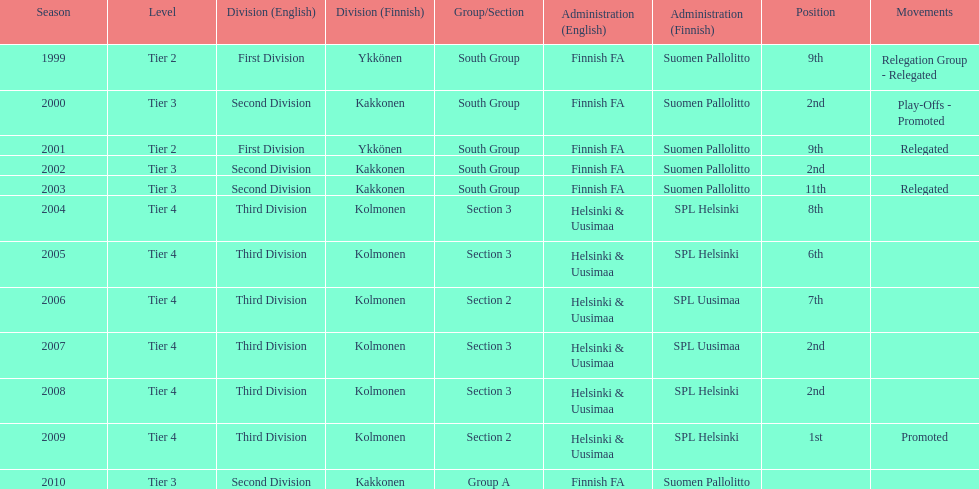How many consecutive times did they play in tier 4? 6. 